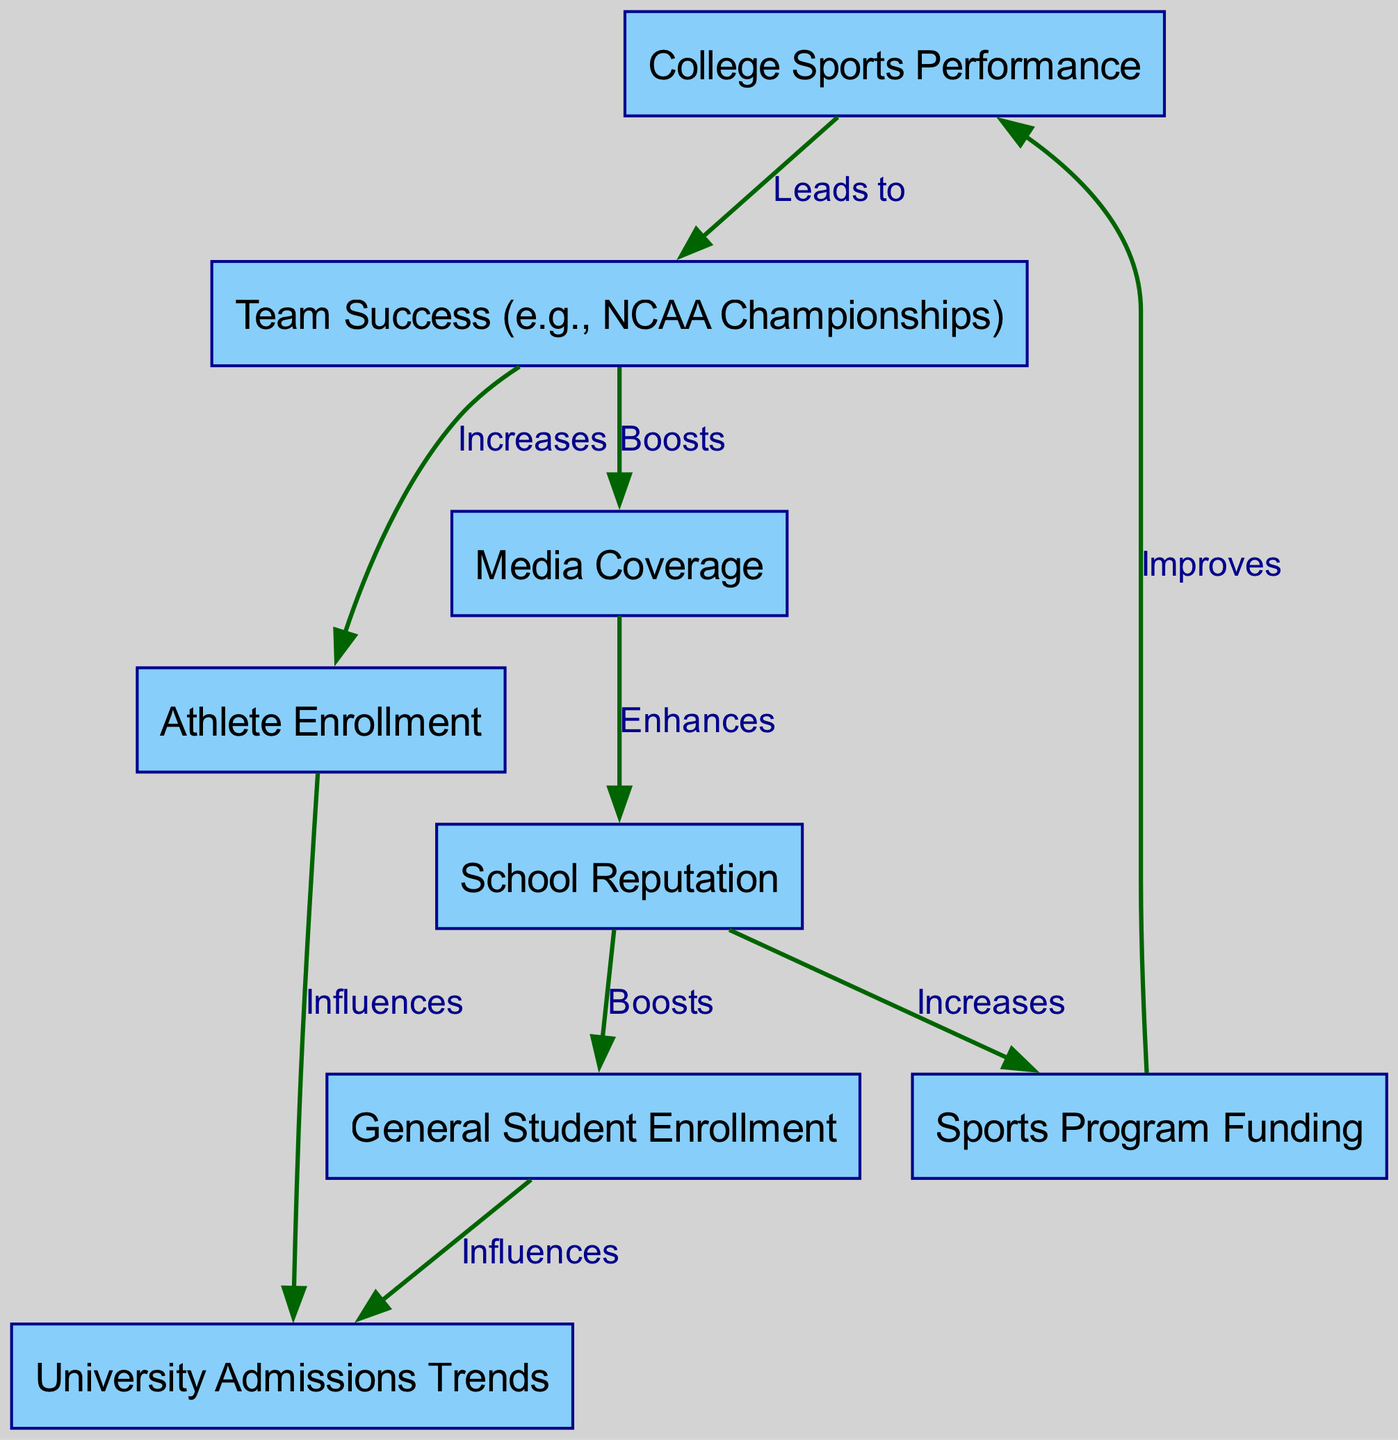What are the main nodes in the diagram? The main nodes are identified as: College Sports Performance, University Admissions Trends, Team Success, Athlete Enrollment, General Student Enrollment, Media Coverage, School Reputation, and Sports Program Funding.
Answer: College Sports Performance, University Admissions Trends, Team Success, Athlete Enrollment, General Student Enrollment, Media Coverage, School Reputation, Sports Program Funding How many nodes are present in the diagram? The diagram contains a total of eight distinct nodes, each representing a key aspect related to college sports and admissions.
Answer: 8 What is the relationship between Team Success and Media Coverage? The relationship is indicated as "Boosts," meaning that Team Success has a positive effect on Media Coverage according to the diagram.
Answer: Boosts What does Media Coverage enhance? According to the diagram, Media Coverage enhances School Reputation, establishing a direct influence on the university's perceived value.
Answer: School Reputation Which factor influences Athlete Enrollment? Team Success is shown as influencing Athlete Enrollment, suggesting that higher success rates lead to more athletes enrolling in the university.
Answer: Team Success Which two elements influence Admissions Trends? The elements are Athlete Enrollment and General Student Enrollment, indicating that both these factors play a role in determining the trends of university admissions.
Answer: Athlete Enrollment, General Student Enrollment What is the flow from Sports Program Funding to College Sports Performance? The flow is described as "Improves," signifying that increased funding directly enhances the College Sports Performance.
Answer: Improves How does School Reputation impact General Student Enrollment? The diagram states that School Reputation boosts General Student Enrollment, meaning a better reputation leads to more general students enrolling.
Answer: Boosts What sequence of influences is observed from Team Success to Admissions Trends? The sequence is: Team Success leads to Athlete Enrollment, which influences Admissions Trends, indicating a direct pathway from athletic success to enrollment trends.
Answer: Team Success, Athlete Enrollment, Admissions Trends 